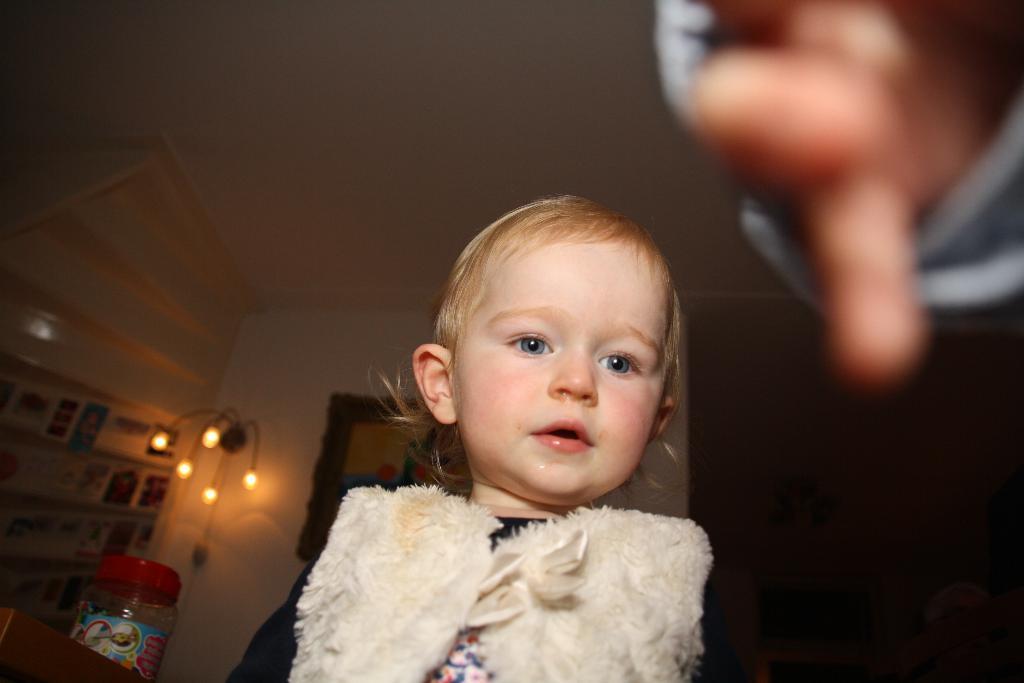Could you give a brief overview of what you see in this image? In this image we can see a kid and a person's hand, there are some objects on the shelves and also we can see some lights and a bottle, in the background we can see the wall. 